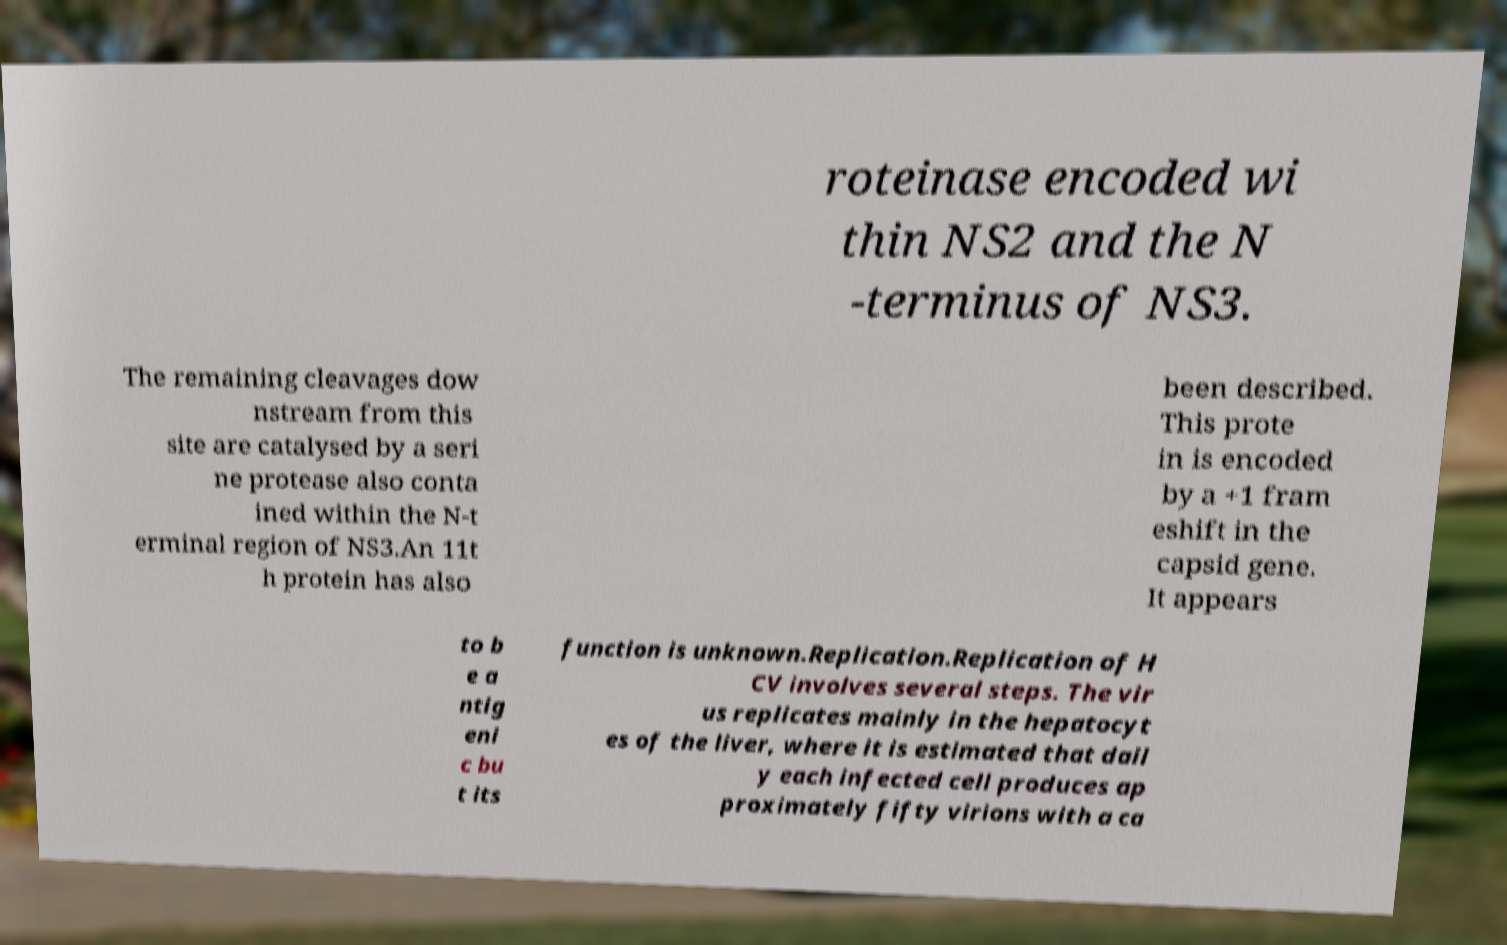For documentation purposes, I need the text within this image transcribed. Could you provide that? roteinase encoded wi thin NS2 and the N -terminus of NS3. The remaining cleavages dow nstream from this site are catalysed by a seri ne protease also conta ined within the N-t erminal region of NS3.An 11t h protein has also been described. This prote in is encoded by a +1 fram eshift in the capsid gene. It appears to b e a ntig eni c bu t its function is unknown.Replication.Replication of H CV involves several steps. The vir us replicates mainly in the hepatocyt es of the liver, where it is estimated that dail y each infected cell produces ap proximately fifty virions with a ca 